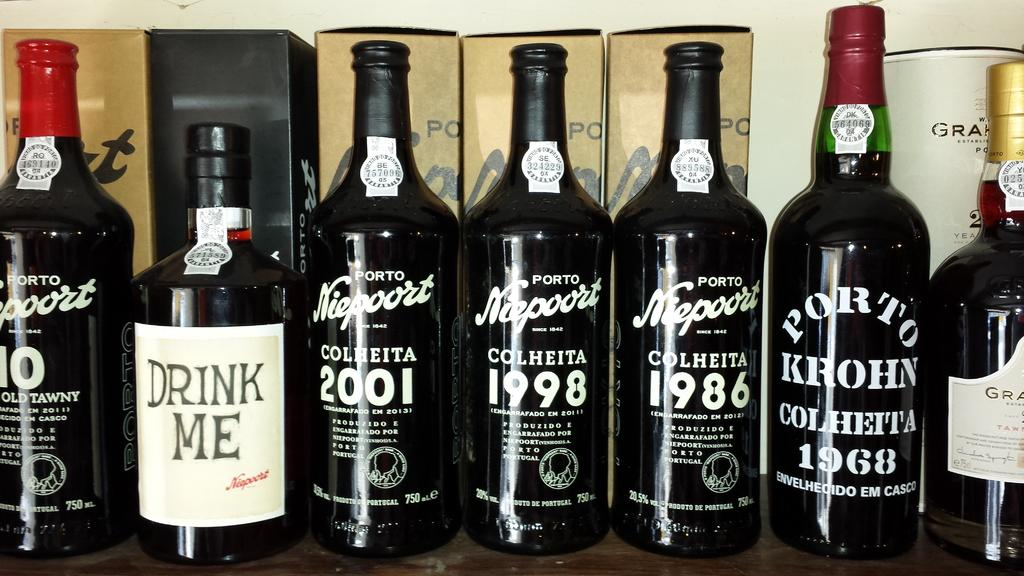<image>
Present a compact description of the photo's key features. A bottle has a label on it that says Drink Me. 